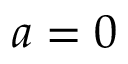Convert formula to latex. <formula><loc_0><loc_0><loc_500><loc_500>a = 0</formula> 